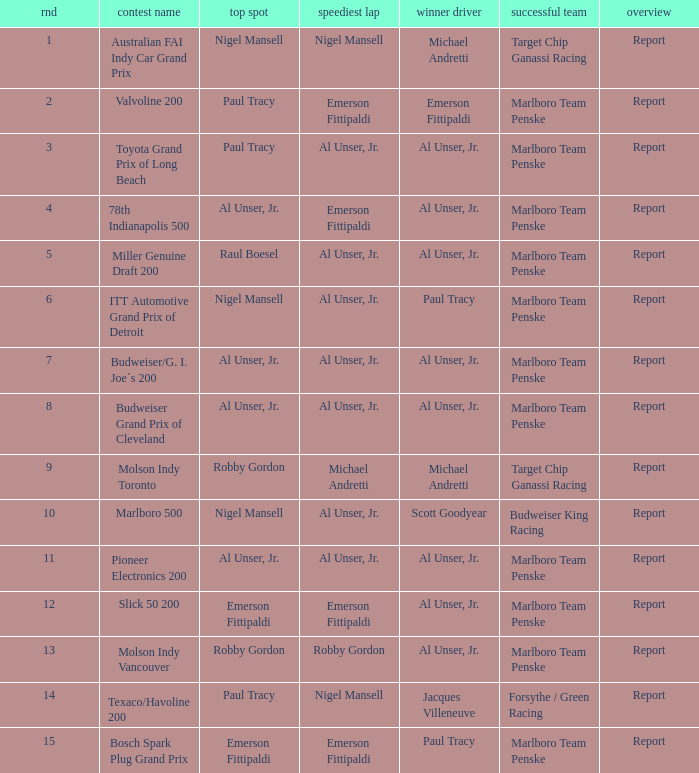Who was on the pole position in the Texaco/Havoline 200 race? Paul Tracy. 